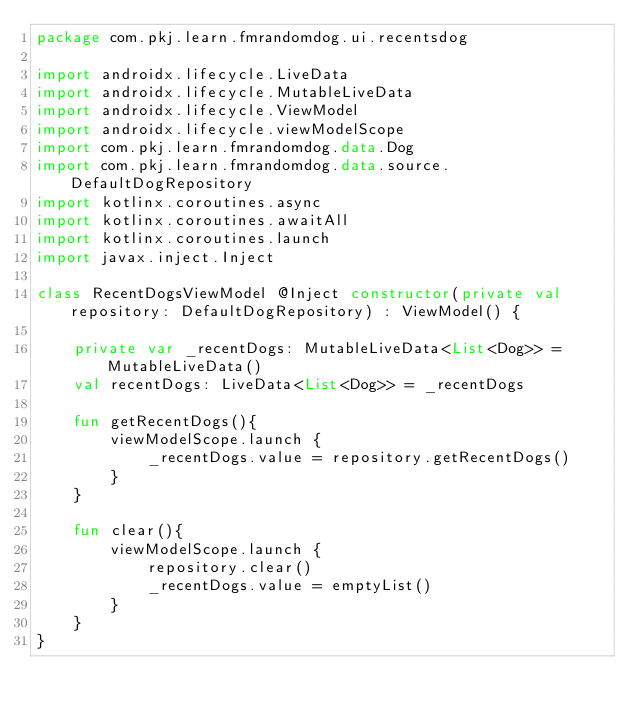<code> <loc_0><loc_0><loc_500><loc_500><_Kotlin_>package com.pkj.learn.fmrandomdog.ui.recentsdog

import androidx.lifecycle.LiveData
import androidx.lifecycle.MutableLiveData
import androidx.lifecycle.ViewModel
import androidx.lifecycle.viewModelScope
import com.pkj.learn.fmrandomdog.data.Dog
import com.pkj.learn.fmrandomdog.data.source.DefaultDogRepository
import kotlinx.coroutines.async
import kotlinx.coroutines.awaitAll
import kotlinx.coroutines.launch
import javax.inject.Inject

class RecentDogsViewModel @Inject constructor(private val repository: DefaultDogRepository) : ViewModel() {

    private var _recentDogs: MutableLiveData<List<Dog>> = MutableLiveData()
    val recentDogs: LiveData<List<Dog>> = _recentDogs

    fun getRecentDogs(){
        viewModelScope.launch {
            _recentDogs.value = repository.getRecentDogs()
        }
    }

    fun clear(){
        viewModelScope.launch {
            repository.clear()
            _recentDogs.value = emptyList()
        }
    }
}
</code> 